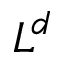Convert formula to latex. <formula><loc_0><loc_0><loc_500><loc_500>L ^ { d }</formula> 